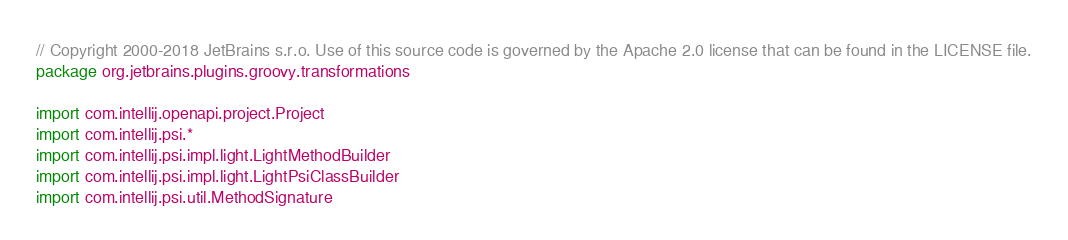<code> <loc_0><loc_0><loc_500><loc_500><_Kotlin_>// Copyright 2000-2018 JetBrains s.r.o. Use of this source code is governed by the Apache 2.0 license that can be found in the LICENSE file.
package org.jetbrains.plugins.groovy.transformations

import com.intellij.openapi.project.Project
import com.intellij.psi.*
import com.intellij.psi.impl.light.LightMethodBuilder
import com.intellij.psi.impl.light.LightPsiClassBuilder
import com.intellij.psi.util.MethodSignature</code> 